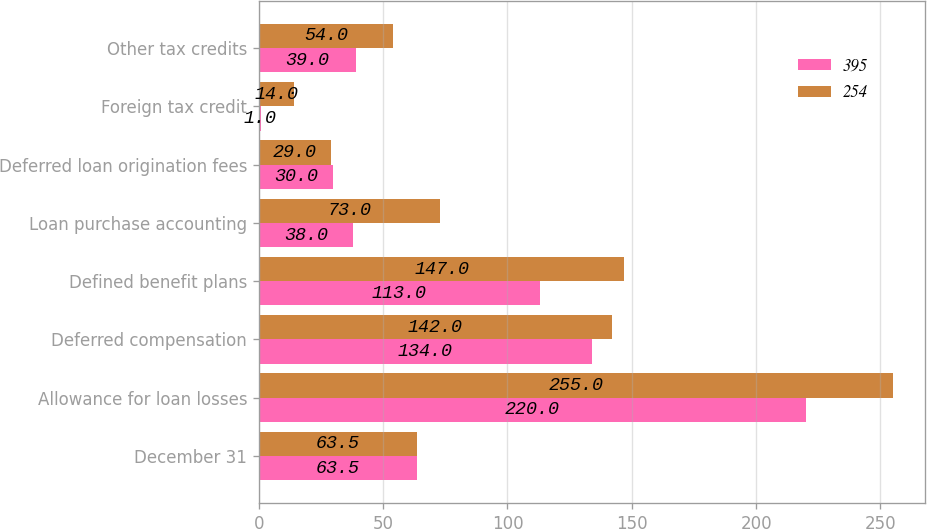Convert chart to OTSL. <chart><loc_0><loc_0><loc_500><loc_500><stacked_bar_chart><ecel><fcel>December 31<fcel>Allowance for loan losses<fcel>Deferred compensation<fcel>Defined benefit plans<fcel>Loan purchase accounting<fcel>Deferred loan origination fees<fcel>Foreign tax credit<fcel>Other tax credits<nl><fcel>395<fcel>63.5<fcel>220<fcel>134<fcel>113<fcel>38<fcel>30<fcel>1<fcel>39<nl><fcel>254<fcel>63.5<fcel>255<fcel>142<fcel>147<fcel>73<fcel>29<fcel>14<fcel>54<nl></chart> 